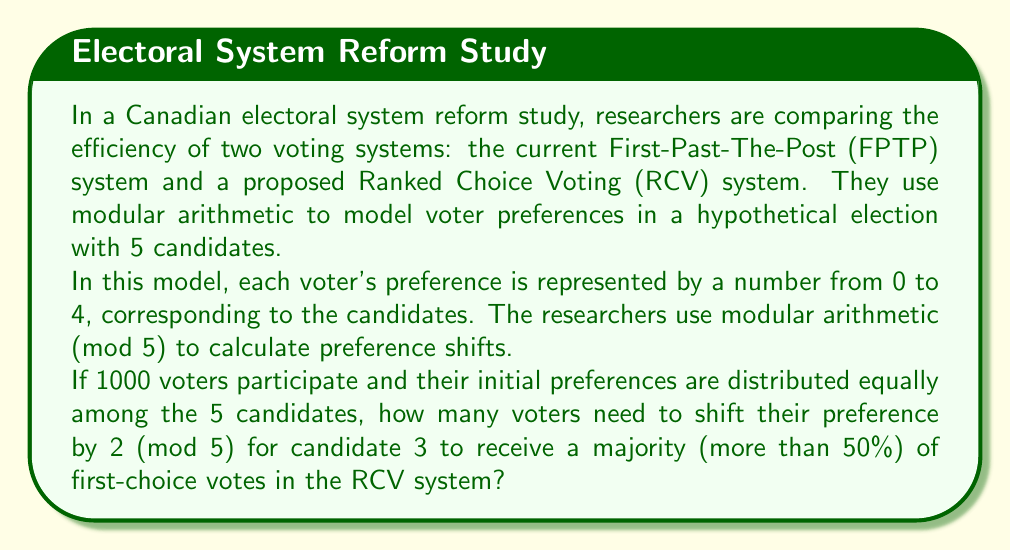Give your solution to this math problem. Let's approach this step-by-step:

1) Initially, with 1000 voters distributed equally among 5 candidates, each candidate has 200 first-choice votes.

2) Candidate 3 needs more than 50% of the votes to win, which is more than 500 votes.

3) Let $x$ be the number of voters who need to shift their preference. These voters will move their preference by 2 (mod 5).

4) In modular arithmetic (mod 5), shifting by 2 from each candidate will result in:
   
   0 → 2
   1 → 3
   2 → 4
   3 → 0
   4 → 1

5) This means that candidate 3 will receive additional votes from voters who initially preferred candidates 0 and 1.

6) We can set up an equation:

   $$200 + x = 501$$

   where 200 is the initial number of votes for candidate 3, and 501 is the minimum number of votes needed for a majority.

7) Solving for $x$:

   $$x = 501 - 200 = 301$$

8) However, we need to ensure that there are enough voters from candidates 0 and 1 to shift. There are 400 such voters initially.

9) Since 301 < 400, this solution is feasible.
Answer: 301 voters need to shift their preference by 2 (mod 5) for candidate 3 to receive a majority of first-choice votes in the RCV system. 